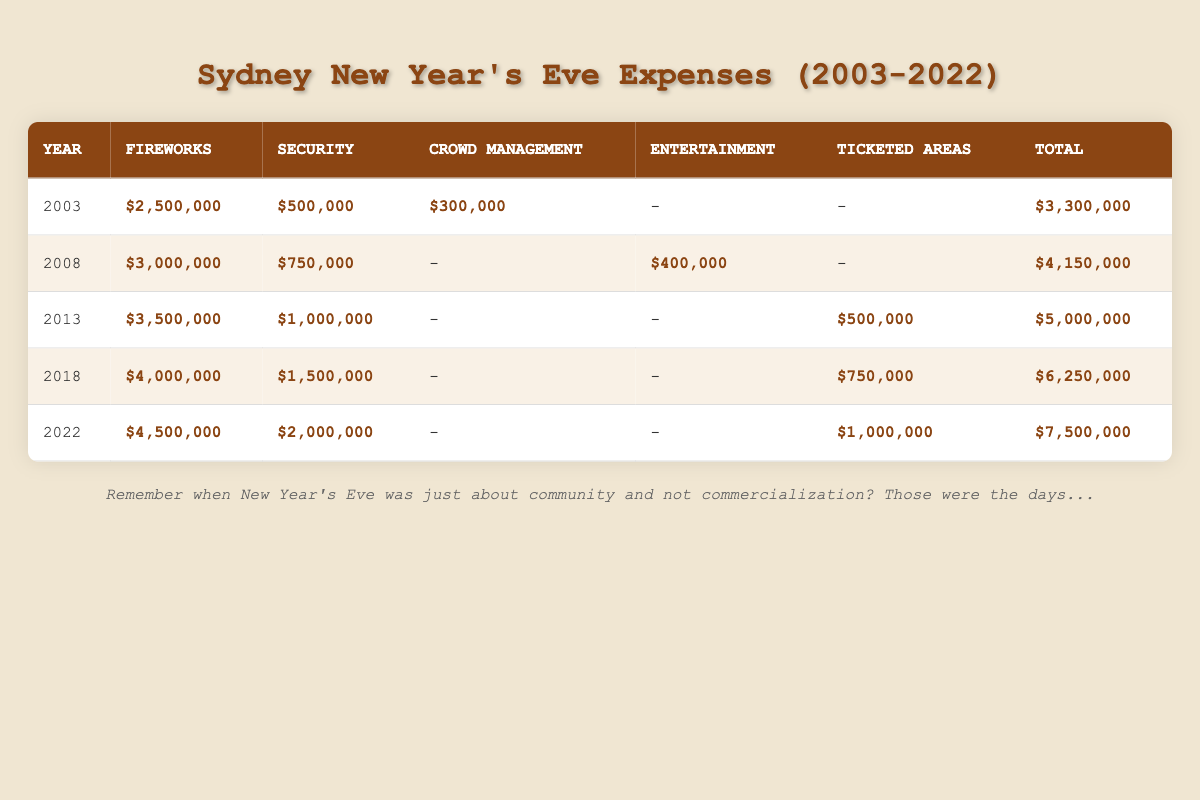What was the total expense for the year 2022? In 2022, the total expense listed in the table is $7,500,000. This is the value from the Total column for that year.
Answer: $7,500,000 Which year had the highest expense on Fireworks? The highest expense on Fireworks is in 2022, amounting to $4,500,000, which is the value from the Fireworks column for that year.
Answer: 2022 What is the average expense for Security over the years listed? To find the average, we sum the Security expenses: $500,000 (2003) + $750,000 (2008) + $1,000,000 (2013) + $1,500,000 (2018) + $2,000,000 (2022) = $6,000,000. There are 5 years, so the average is $6,000,000 / 5 = $1,200,000.
Answer: $1,200,000 In which year did the expenses for Ticketed Areas first appear? Ticketed Areas first appear in 2013, when there is a recorded expense of $500,000. This is verified by checking the Ticketed Areas column for each year.
Answer: 2013 Was the total expense for 2013 greater than the combined expenses for Security in 2008 and 2013? First, we find the total expense for 2013, which is $5,000,000. Then we calculate the combined Security expenses: $750,000 (2008) + $1,000,000 (2013) = $1,750,000. Since $5,000,000 > $1,750,000, the statement is true.
Answer: Yes How much did the City of Sydney sponsor for Crowd Management in 2003? The table indicates that there was a spending of $300,000 in the Crowd Management category sponsored by the City of Sydney in 2003. This can be directly taken from the Crowd Management row for that year.
Answer: $300,000 Which category incurred the least expense in 2008, and what was the expense? In 2008, Crowd Management incurred no expense (denoted by a dash), while the other categories all had expenses. Therefore, Crowd Management is the category with the least expense, which is $0.
Answer: $0 What is the total expense for Fireworks across all available years? The total expense for Fireworks can be calculated by summing the values: $2,500,000 (2003) + $3,000,000 (2008) + $3,500,000 (2013) + $4,000,000 (2018) + $4,500,000 (2022) = $17,000,000.
Answer: $17,000,000 